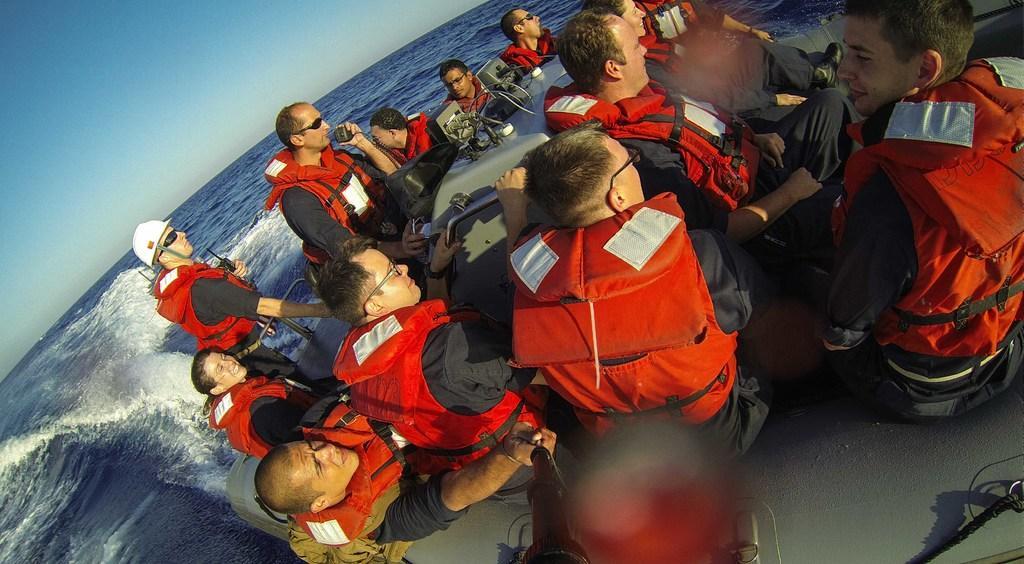Describe this image in one or two sentences. In this image, we can see some persons wearing life jackets and sitting on the boat which is floating on the water. There is a sky in the top left of the image. 